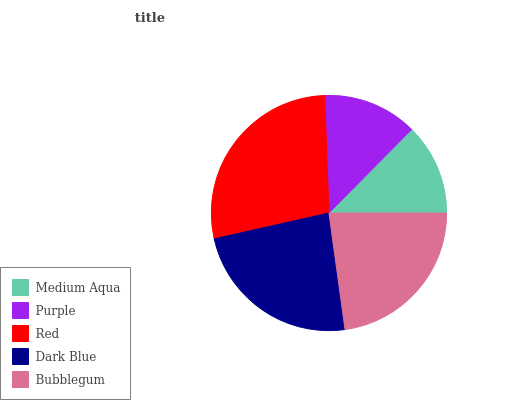Is Medium Aqua the minimum?
Answer yes or no. Yes. Is Red the maximum?
Answer yes or no. Yes. Is Purple the minimum?
Answer yes or no. No. Is Purple the maximum?
Answer yes or no. No. Is Purple greater than Medium Aqua?
Answer yes or no. Yes. Is Medium Aqua less than Purple?
Answer yes or no. Yes. Is Medium Aqua greater than Purple?
Answer yes or no. No. Is Purple less than Medium Aqua?
Answer yes or no. No. Is Bubblegum the high median?
Answer yes or no. Yes. Is Bubblegum the low median?
Answer yes or no. Yes. Is Red the high median?
Answer yes or no. No. Is Dark Blue the low median?
Answer yes or no. No. 